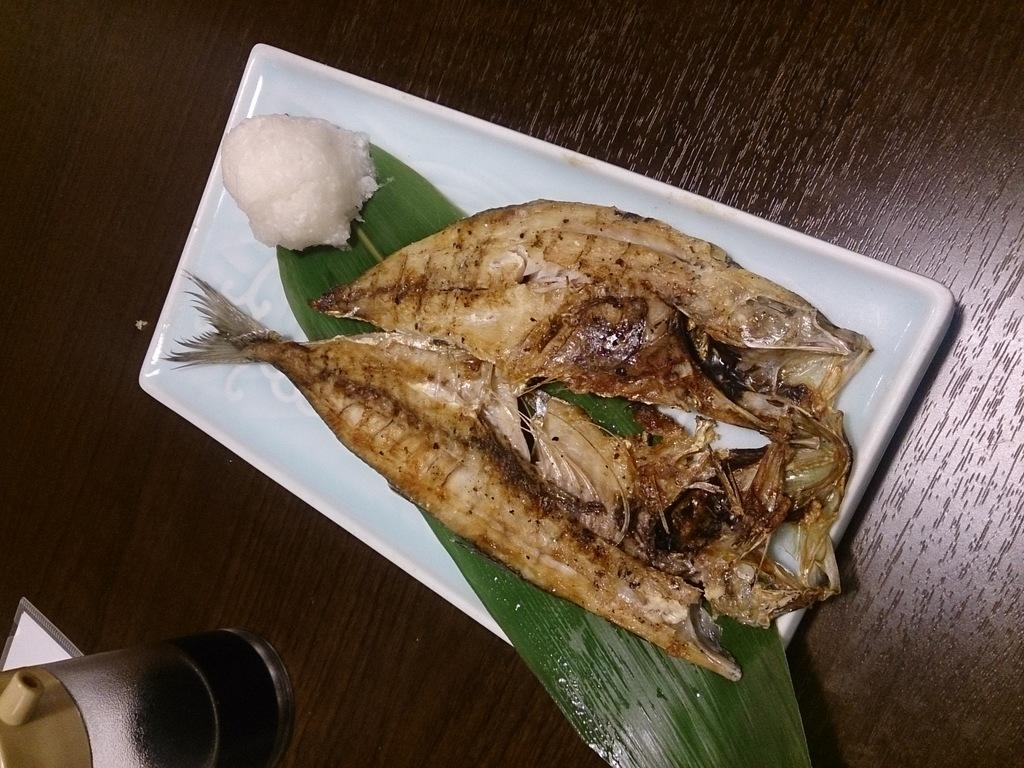What is the main subject of the image? There is a food item in the center of the image. What type of food item is it? Unfortunately, the specific type of food item cannot be determined from the provided facts. What else is present on the table? Leaves are present on a plate, and there is a glass on the table in the bottom left corner. Where is the plate located in the image? The plate is placed on a table. What book is the person reading in the image? There is no person or book present in the image; it features a food item, leaves, a plate, and a glass on a table. 